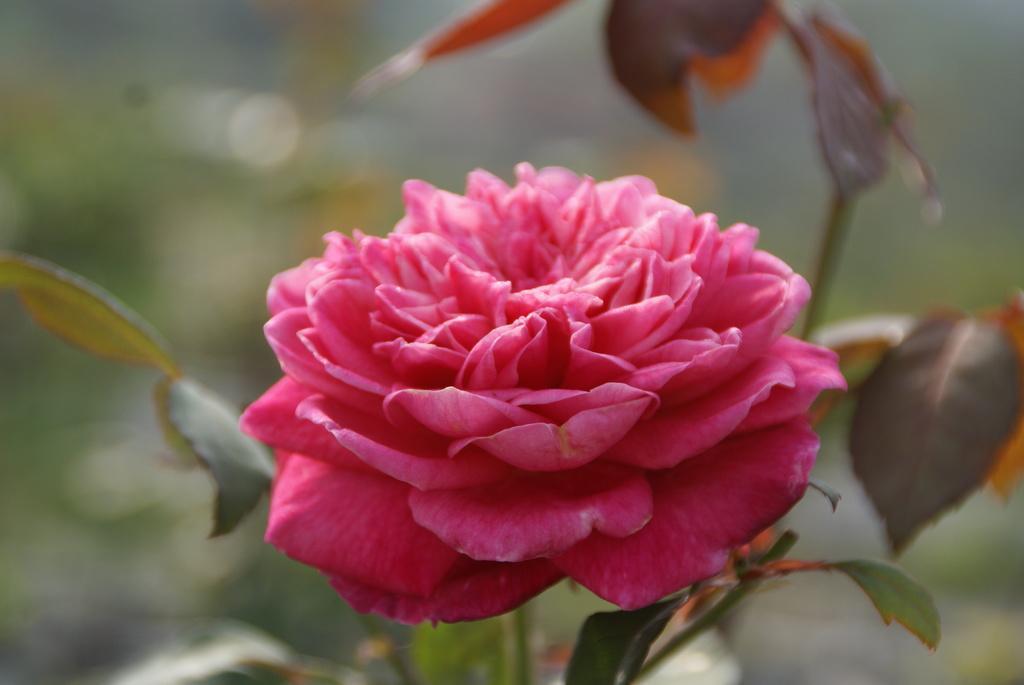In one or two sentences, can you explain what this image depicts? In the image there is a pink flower plant in the front and the background is blurry. 